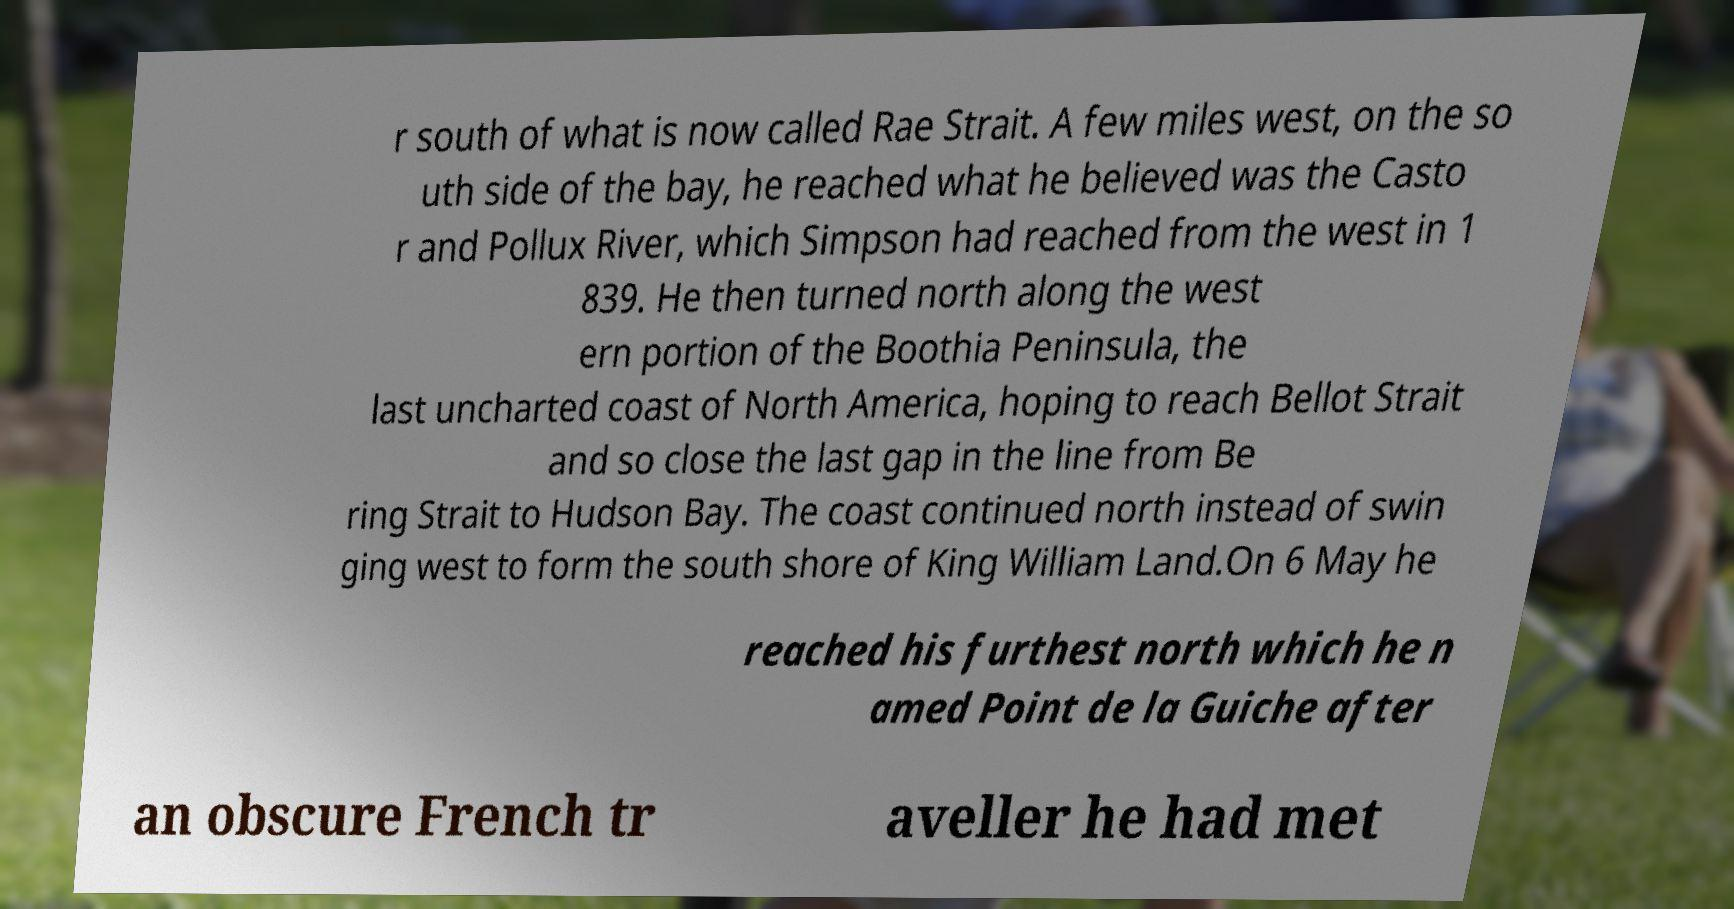Could you assist in decoding the text presented in this image and type it out clearly? r south of what is now called Rae Strait. A few miles west, on the so uth side of the bay, he reached what he believed was the Casto r and Pollux River, which Simpson had reached from the west in 1 839. He then turned north along the west ern portion of the Boothia Peninsula, the last uncharted coast of North America, hoping to reach Bellot Strait and so close the last gap in the line from Be ring Strait to Hudson Bay. The coast continued north instead of swin ging west to form the south shore of King William Land.On 6 May he reached his furthest north which he n amed Point de la Guiche after an obscure French tr aveller he had met 